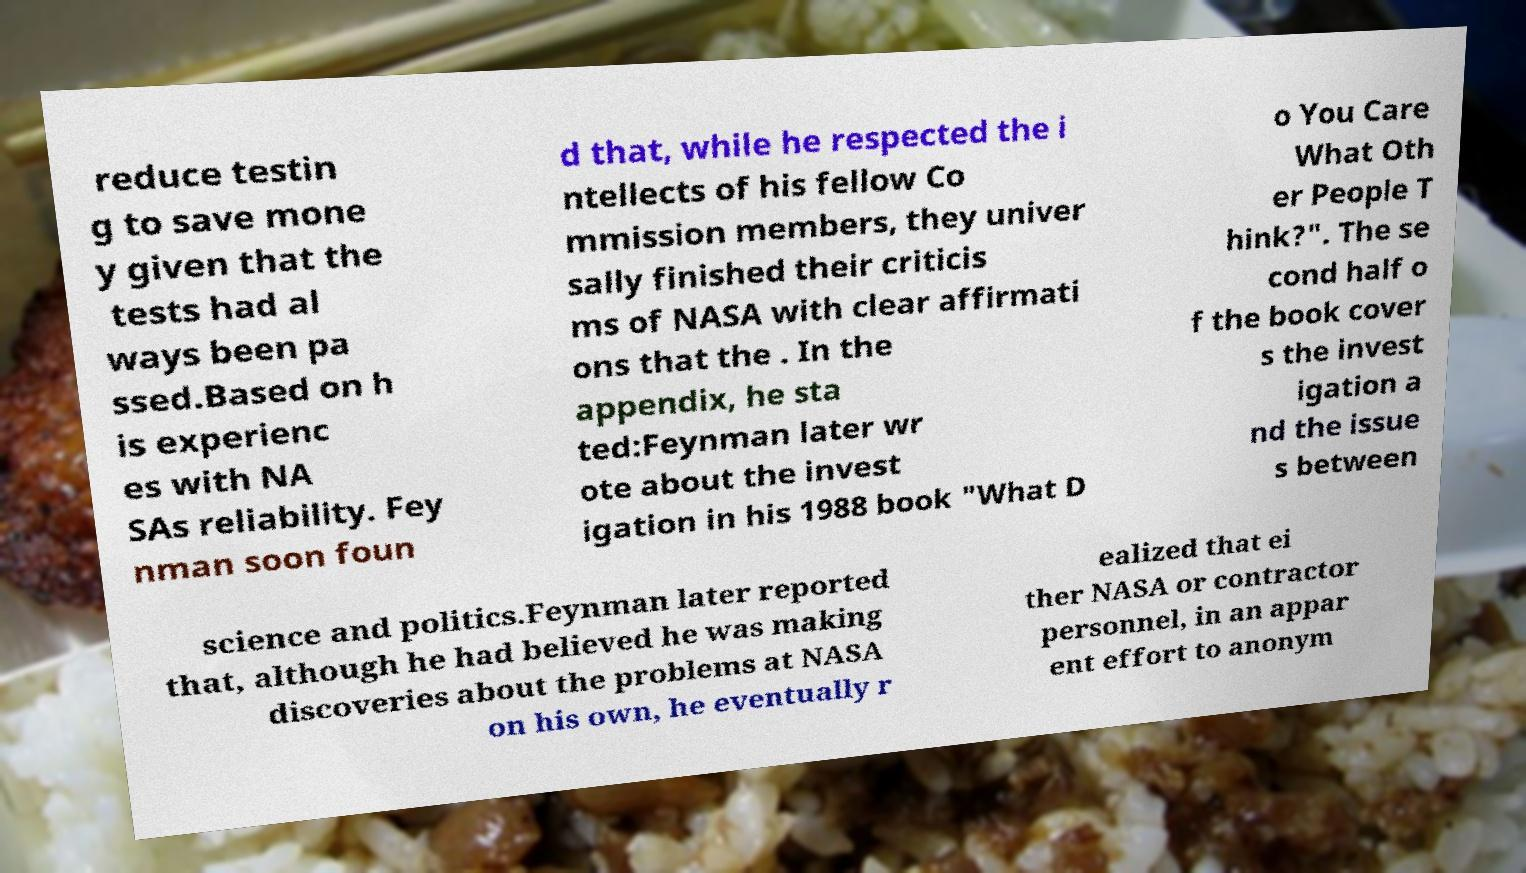What messages or text are displayed in this image? I need them in a readable, typed format. reduce testin g to save mone y given that the tests had al ways been pa ssed.Based on h is experienc es with NA SAs reliability. Fey nman soon foun d that, while he respected the i ntellects of his fellow Co mmission members, they univer sally finished their criticis ms of NASA with clear affirmati ons that the . In the appendix, he sta ted:Feynman later wr ote about the invest igation in his 1988 book "What D o You Care What Oth er People T hink?". The se cond half o f the book cover s the invest igation a nd the issue s between science and politics.Feynman later reported that, although he had believed he was making discoveries about the problems at NASA on his own, he eventually r ealized that ei ther NASA or contractor personnel, in an appar ent effort to anonym 